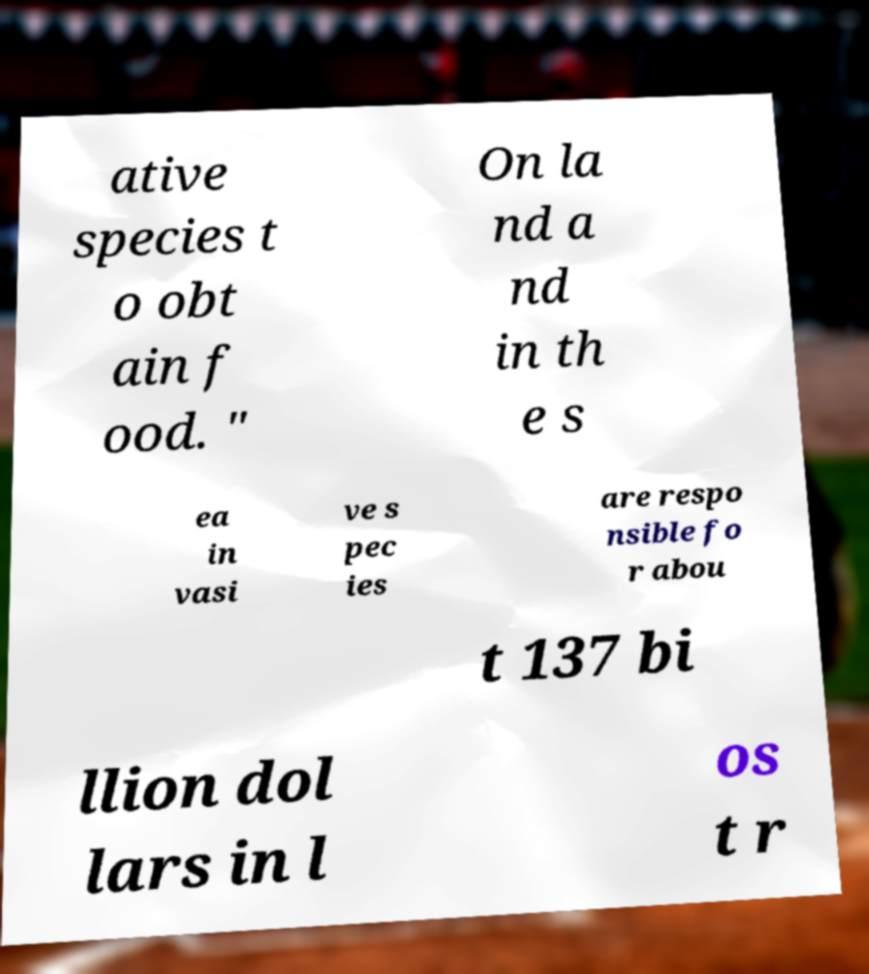What messages or text are displayed in this image? I need them in a readable, typed format. ative species t o obt ain f ood. " On la nd a nd in th e s ea in vasi ve s pec ies are respo nsible fo r abou t 137 bi llion dol lars in l os t r 